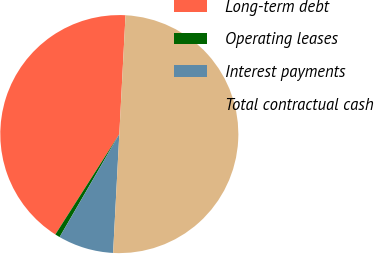Convert chart to OTSL. <chart><loc_0><loc_0><loc_500><loc_500><pie_chart><fcel>Long-term debt<fcel>Operating leases<fcel>Interest payments<fcel>Total contractual cash<nl><fcel>41.8%<fcel>0.67%<fcel>7.53%<fcel>50.0%<nl></chart> 